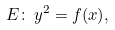<formula> <loc_0><loc_0><loc_500><loc_500>E \colon \, y ^ { 2 } = f ( x ) ,</formula> 